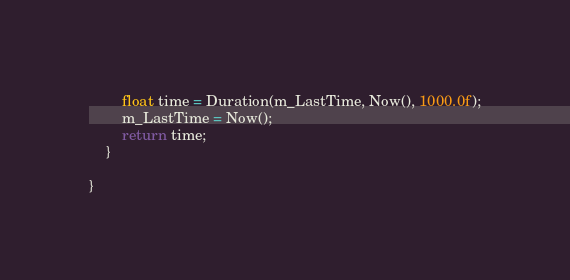Convert code to text. <code><loc_0><loc_0><loc_500><loc_500><_C++_>		float time = Duration(m_LastTime, Now(), 1000.0f);
		m_LastTime = Now();
		return time;
	}

}
</code> 